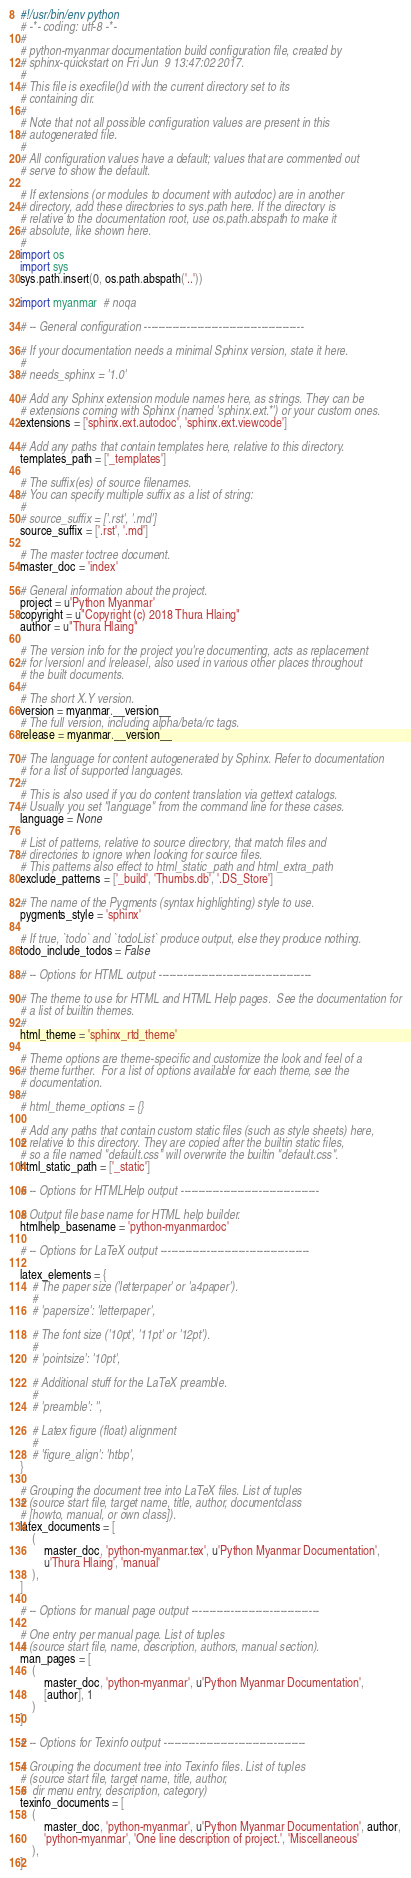<code> <loc_0><loc_0><loc_500><loc_500><_Python_>#!/usr/bin/env python
# -*- coding: utf-8 -*-
#
# python-myanmar documentation build configuration file, created by
# sphinx-quickstart on Fri Jun  9 13:47:02 2017.
#
# This file is execfile()d with the current directory set to its
# containing dir.
#
# Note that not all possible configuration values are present in this
# autogenerated file.
#
# All configuration values have a default; values that are commented out
# serve to show the default.

# If extensions (or modules to document with autodoc) are in another
# directory, add these directories to sys.path here. If the directory is
# relative to the documentation root, use os.path.abspath to make it
# absolute, like shown here.
#
import os
import sys
sys.path.insert(0, os.path.abspath('..'))

import myanmar  # noqa

# -- General configuration ---------------------------------------------

# If your documentation needs a minimal Sphinx version, state it here.
#
# needs_sphinx = '1.0'

# Add any Sphinx extension module names here, as strings. They can be
# extensions coming with Sphinx (named 'sphinx.ext.*') or your custom ones.
extensions = ['sphinx.ext.autodoc', 'sphinx.ext.viewcode']

# Add any paths that contain templates here, relative to this directory.
templates_path = ['_templates']

# The suffix(es) of source filenames.
# You can specify multiple suffix as a list of string:
#
# source_suffix = ['.rst', '.md']
source_suffix = ['.rst', '.md']

# The master toctree document.
master_doc = 'index'

# General information about the project.
project = u'Python Myanmar'
copyright = u"Copyright (c) 2018 Thura Hlaing"
author = u"Thura Hlaing"

# The version info for the project you're documenting, acts as replacement
# for |version| and |release|, also used in various other places throughout
# the built documents.
#
# The short X.Y version.
version = myanmar.__version__
# The full version, including alpha/beta/rc tags.
release = myanmar.__version__

# The language for content autogenerated by Sphinx. Refer to documentation
# for a list of supported languages.
#
# This is also used if you do content translation via gettext catalogs.
# Usually you set "language" from the command line for these cases.
language = None

# List of patterns, relative to source directory, that match files and
# directories to ignore when looking for source files.
# This patterns also effect to html_static_path and html_extra_path
exclude_patterns = ['_build', 'Thumbs.db', '.DS_Store']

# The name of the Pygments (syntax highlighting) style to use.
pygments_style = 'sphinx'

# If true, `todo` and `todoList` produce output, else they produce nothing.
todo_include_todos = False

# -- Options for HTML output -------------------------------------------

# The theme to use for HTML and HTML Help pages.  See the documentation for
# a list of builtin themes.
#
html_theme = 'sphinx_rtd_theme'

# Theme options are theme-specific and customize the look and feel of a
# theme further.  For a list of options available for each theme, see the
# documentation.
#
# html_theme_options = {}

# Add any paths that contain custom static files (such as style sheets) here,
# relative to this directory. They are copied after the builtin static files,
# so a file named "default.css" will overwrite the builtin "default.css".
html_static_path = ['_static']

# -- Options for HTMLHelp output ---------------------------------------

# Output file base name for HTML help builder.
htmlhelp_basename = 'python-myanmardoc'

# -- Options for LaTeX output ------------------------------------------

latex_elements = {
    # The paper size ('letterpaper' or 'a4paper').
    #
    # 'papersize': 'letterpaper',

    # The font size ('10pt', '11pt' or '12pt').
    #
    # 'pointsize': '10pt',

    # Additional stuff for the LaTeX preamble.
    #
    # 'preamble': '',

    # Latex figure (float) alignment
    #
    # 'figure_align': 'htbp',
}

# Grouping the document tree into LaTeX files. List of tuples
# (source start file, target name, title, author, documentclass
# [howto, manual, or own class]).
latex_documents = [
    (
        master_doc, 'python-myanmar.tex', u'Python Myanmar Documentation',
        u'Thura Hlaing', 'manual'
    ),
]

# -- Options for manual page output ------------------------------------

# One entry per manual page. List of tuples
# (source start file, name, description, authors, manual section).
man_pages = [
    (
        master_doc, 'python-myanmar', u'Python Myanmar Documentation',
        [author], 1
    )
]

# -- Options for Texinfo output ----------------------------------------

# Grouping the document tree into Texinfo files. List of tuples
# (source start file, target name, title, author,
#  dir menu entry, description, category)
texinfo_documents = [
    (
        master_doc, 'python-myanmar', u'Python Myanmar Documentation', author,
        'python-myanmar', 'One line description of project.', 'Miscellaneous'
    ),
]
</code> 